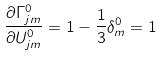Convert formula to latex. <formula><loc_0><loc_0><loc_500><loc_500>\frac { \partial \Gamma ^ { 0 } _ { j m } } { \partial U ^ { 0 } _ { j m } } = 1 - \frac { 1 } { 3 } \delta ^ { 0 } _ { m } = 1</formula> 